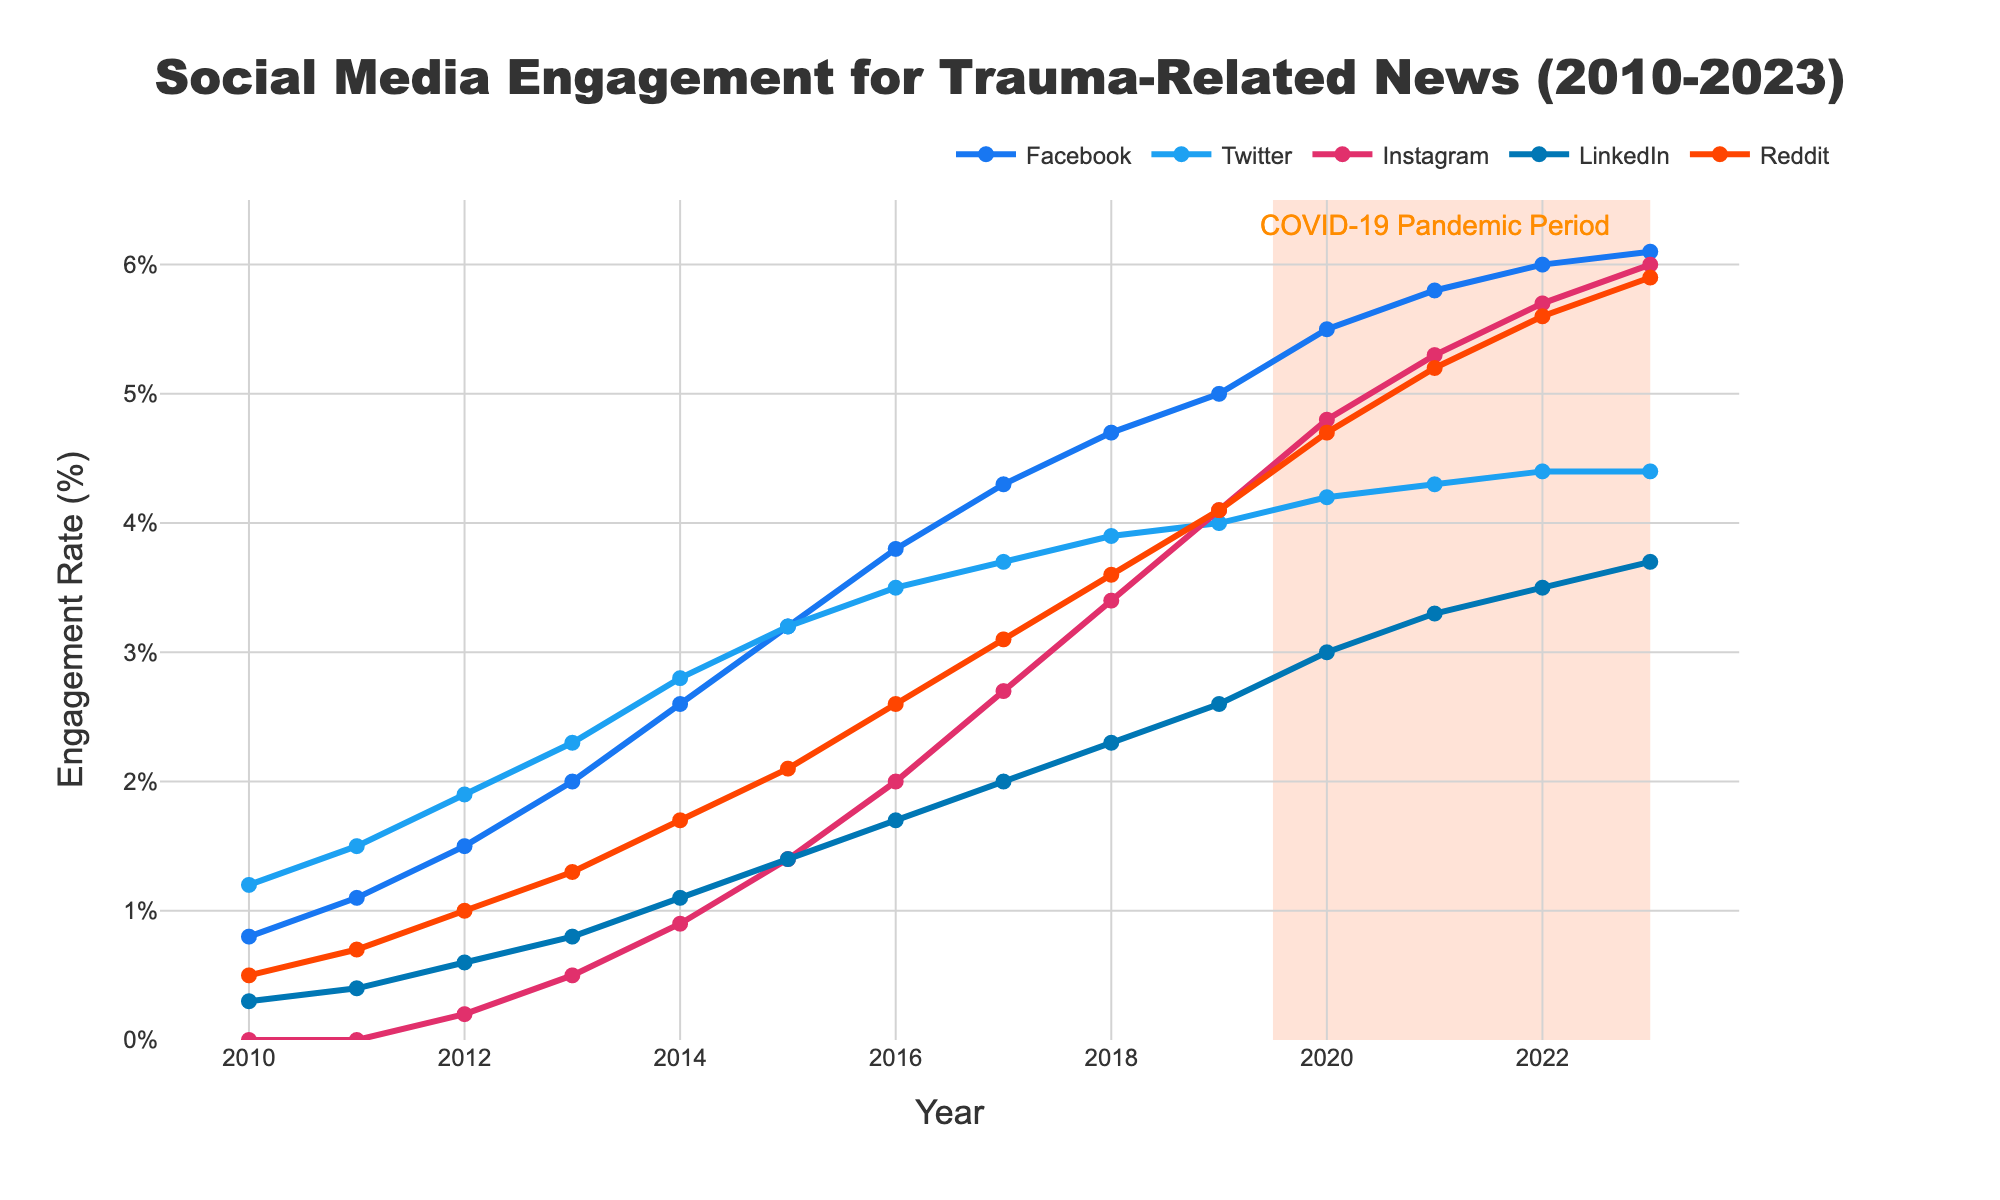What is the engagement rate for Instagram in 2015? Find the Instagram data point for the year 2015.
Answer: 1.4 Which platform had the highest engagement rate in 2019? Compare the engagement rates of all platforms for the year 2019.
Answer: Facebook How did the engagement rate on Twitter change from 2010 to 2023? Calculate the difference between the engagement rate of Twitter in 2023 and 2010. 4.4 (2023) - 1.2 (2010) = 3.2
Answer: Increased by 3.2 During which period did Facebook see its most significant engagement rate increase? Identify the time period during which Facebook's engagement rate had the highest linear increase. From 2012 to 2014, engagement increased from 1.5% to 2.6%, which is a 1.1% increase. 2014 to 2016 saw a rise of 1.2% (from 2.6% to 3.8%). 2019 to 2020 saw an increase of 0.5% (from 5.0% to 5.5%).
Answer: 2014 to 2016 Compare the engagement rate changes for LinkedIn and Reddit in the year 2020. Look at the engagement rates for both LinkedIn and Reddit in 2019 and 2020, then calculate the change for each. Reddit increased from 4.1% (2019) to 4.7% (2020), which is a 0.6% increase. LinkedIn increased from 2.6% (2019) to 3.0% (2020), which is a 0.4% increase.
Answer: Reddit increased more than LinkedIn What was the average engagement rate on Reddit between 2018 and 2020? Add the engagement rates for Reddit from 2018 to 2020 and divide by the number of years. (3.6 + 4.1 + 4.7) / 3 = 4.13
Answer: 4.13 Which platform showed the least variability in engagement rates over the years? Examine the engagement rates for all platforms from 2010 to 2023 and identify the one with the smallest range of values. Instagram starts at 0.0 and grows linearly to 6.0 with consistent increases. LinkedIn starts at 0.3 and grows evenly to 3.7. Facebook and Twitter have higher initial and final values.
Answer: LinkedIn How much did the engagement rate of Instagram increase from 2016 to 2021? Measure the difference between Instagram's engagement rate in 2016 and 2021. 5.3 (2021) - 2.0 (2016) = 3.3
Answer: 3.3 Identify the year when LinkedIn's engagement rate surpassed 2.0%. Find the first year when LinkedIn's engagement rate was above 2.0%. LinkedIn reached an engagement rate of 2.0% or higher in 2017.
Answer: 2017 Which platform showed the most growth during the highlighted period indicating the COVID-19 pandemic? Compare the engagement rate growth of each platform between 2019 and 2023. Facebook increased from 5.0 (2019) to 6.1 (2023), Twitter from 4.0 (2019) to 4.4 (2023), Instagram from 4.1 (2019) to 6.0 (2023), LinkedIn from 2.6 (2019) to 3.7 (2023), Reddit from 4.1 (2019) to 5.9 (2023).
Answer: Instagram 